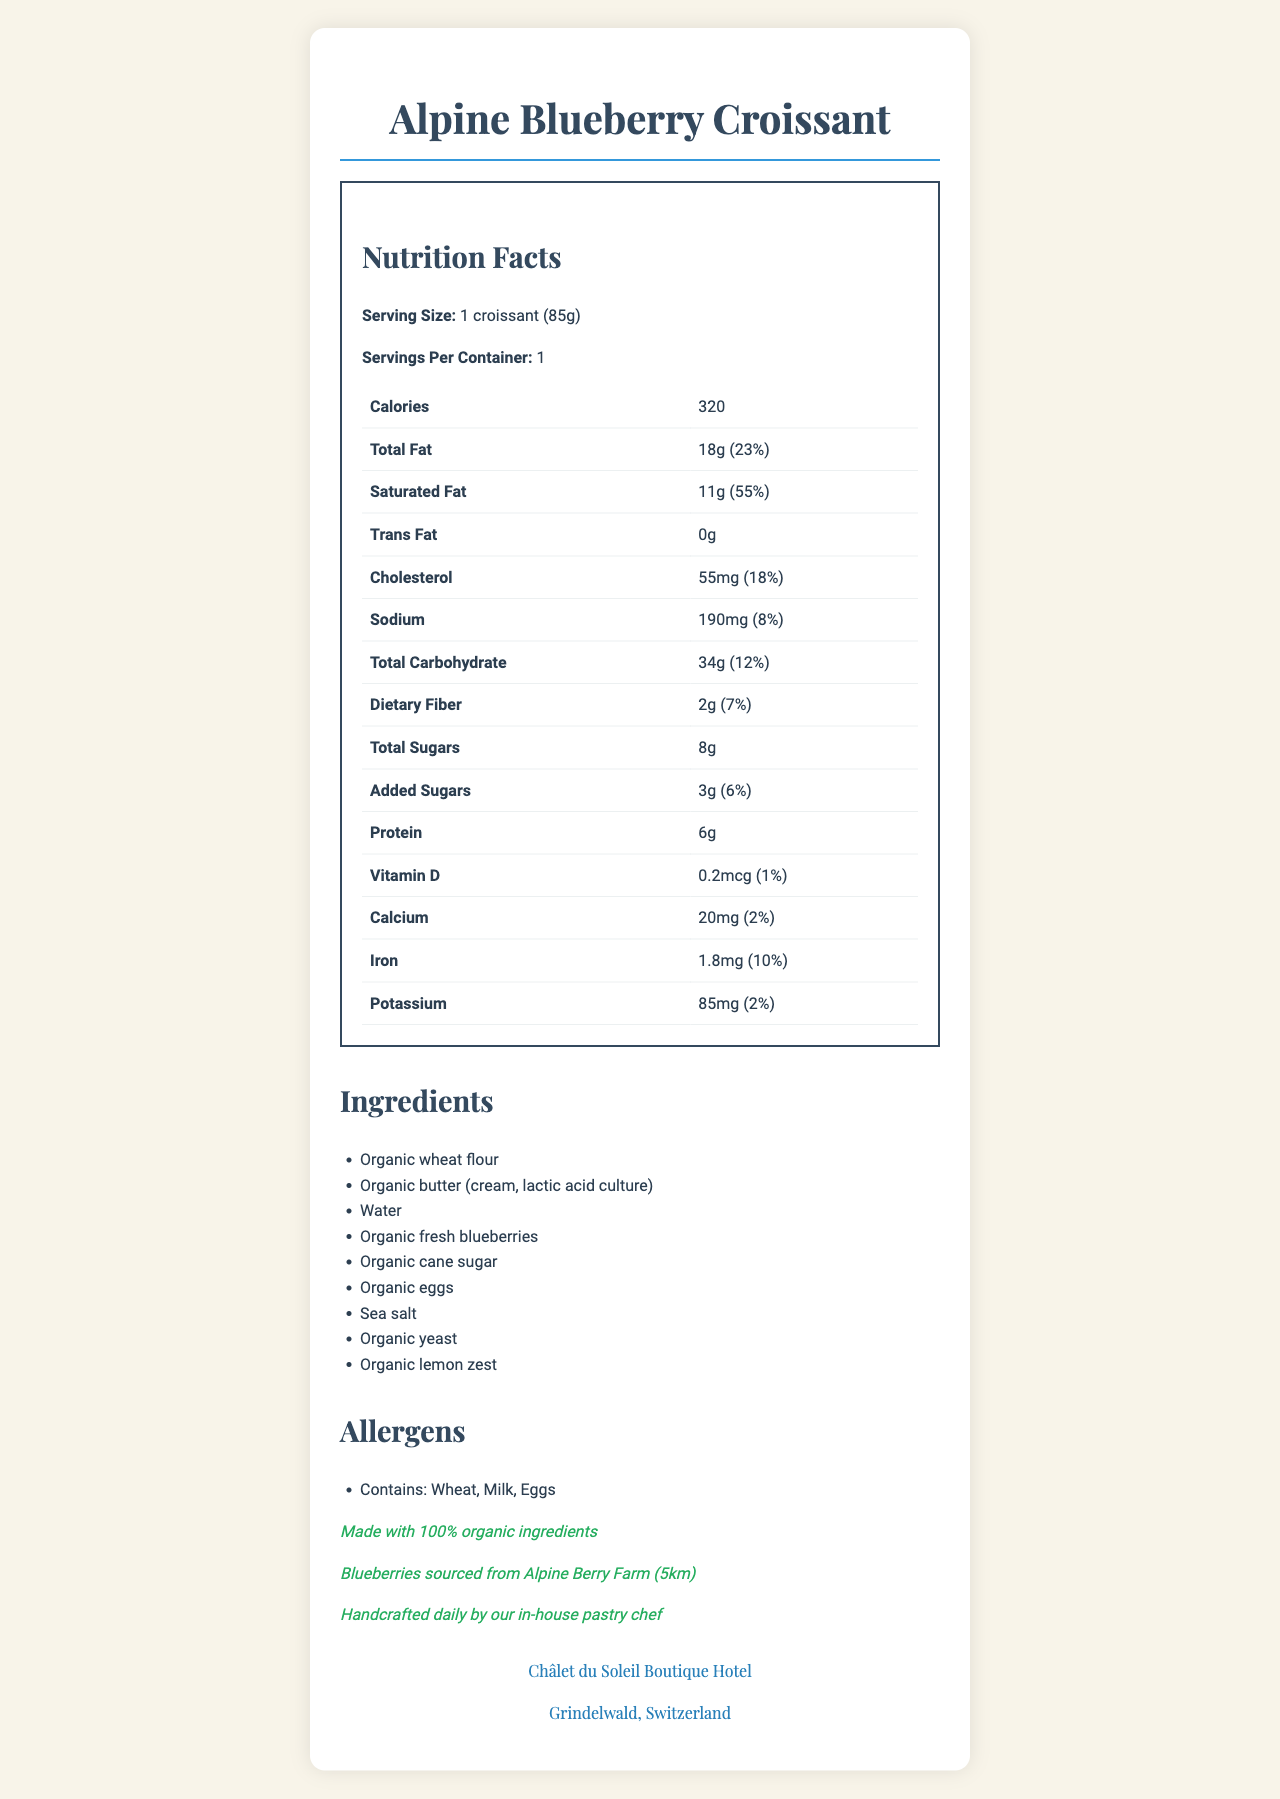what is the serving size? The serving size is clearly stated near the top of the Nutrition Facts section.
Answer: 1 croissant (85g) how many calories are in the Alpine Blueberry Croissant? The number of calories is listed in the nutrition table.
Answer: 320 what percentage of daily value does the total fat represent? The daily value percentage for total fat is displayed next to its amount in the nutrition table.
Answer: 23% what are the first three ingredients listed? The ingredients are listed in order by weight, and the first three are shown in the Ingredients section.
Answer: Organic wheat flour, Organic butter (cream, lactic acid culture), Water which allergens are present in the Alpine Blueberry Croissant? The allergens are mentioned in the Allergens section.
Answer: Wheat, Milk, Eggs what is the source of the blueberries used in the croissant? The local sourcing information states that blueberries are sourced from Alpine Berry Farm.
Answer: Alpine Berry Farm (5km) how much dietary fiber does the croissant contain per serving? The amount of dietary fiber is shown in the nutrition table under Total Carbohydrate.
Answer: 2g what is the total carbohydrate content in the croissant? The Total Carbohydrate content is listed in the nutrition table.
Answer: 34g how much added sugars are in the croissant? The Added Sugars amount is indicated in the nutrition table beneath Total Sugars.
Answer: 3g what is the daily value percentage of protein in the croissant? The nutrition table shows the amount of protein as 6g, but not the daily value percentage.
Answer: Not specified which statement is true about the croissant's ingredients? A. It contains artificial flavors. B. It includes organic lemon zest. C. It has no added sugars. D. It contains tree nuts. The Ingredients list includes "Organic lemon zest," making option B the correct answer.
Answer: B how is the croissant prepared? A. Machine-made in large batches B. Baked in a local factory C. Handcrafted daily by an in-house pastry chef The document specifies that the croissant is "Handcrafted daily by our in-house pastry chef."
Answer: C is the Alpine Blueberry Croissant made using organic ingredients? The organic statement clearly indicates it is made with 100% organic ingredients.
Answer: Yes what is the daily value percentage of iron in the croissant? The daily value percentage for iron is found in the nutrition table.
Answer: 10% do the croissants contain any vegetarian ingredients? The ingredients such as Organic wheat flour, Organic butter, Water, etc., are vegetarian.
Answer: Yes where is the Châlet du Soleil Boutique Hotel located? The hotel's name and town are mentioned in the hotel info section at the bottom of the document.
Answer: Grindelwald, Switzerland which mineral has the highest daily value percentage in the croissant? Among the listed nutrients, saturated fat has the highest daily value percentage at 55%.
Answer: Saturated Fat (55%) are blueberries the main ingredient in the croissant? Organic wheat flour and Organic butter are listed before blueberries, indicating they are present in greater amounts.
Answer: No summarize the main idea of this document. This summary encompasses the major sections and distinct claims of the document such as nutritional breakdown, ingredients, allergens, artisanal process, and hotel location.
Answer: The document is a Nutrition Facts Label for the Alpine Blueberry Croissant, highlighting its organic ingredients, nutritional content, allergens, local sourcing of blueberries, artisanal preparation, and hotel information. how much vitamin D does the croissant contain? A. 0.2mcg B. 2mg C. 0.02g D. 20mcg The nutrition table lists Vitamin D as 0.2mcg making option A correct.
Answer: A what is the cost of the Alpine Blueberry Croissant? The document does not include any pricing information.
Answer: Not enough information 